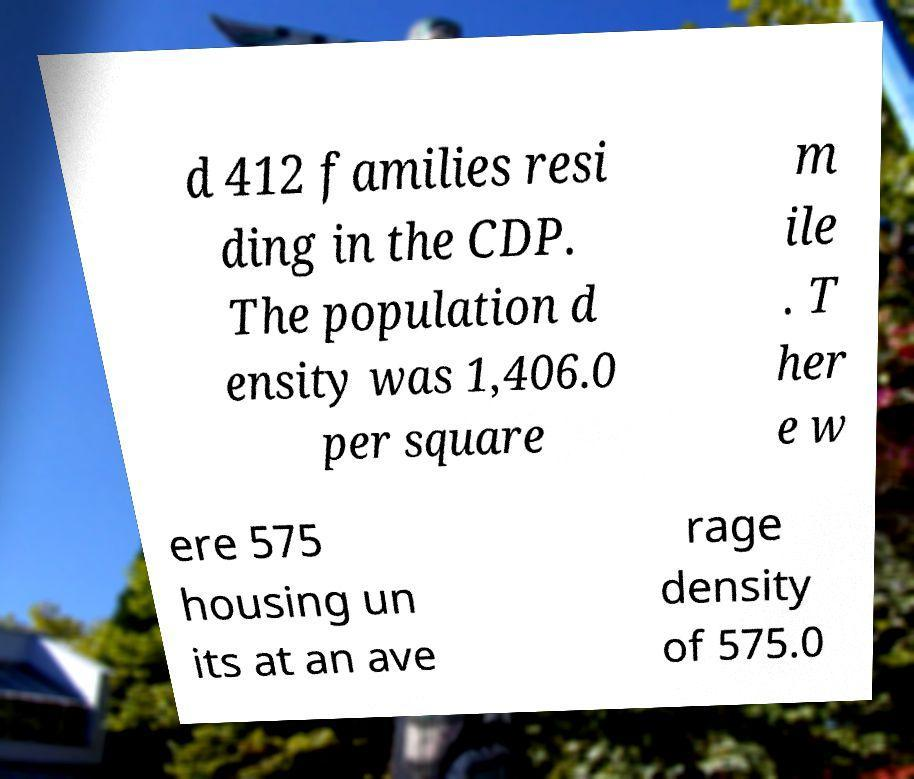Please identify and transcribe the text found in this image. d 412 families resi ding in the CDP. The population d ensity was 1,406.0 per square m ile . T her e w ere 575 housing un its at an ave rage density of 575.0 